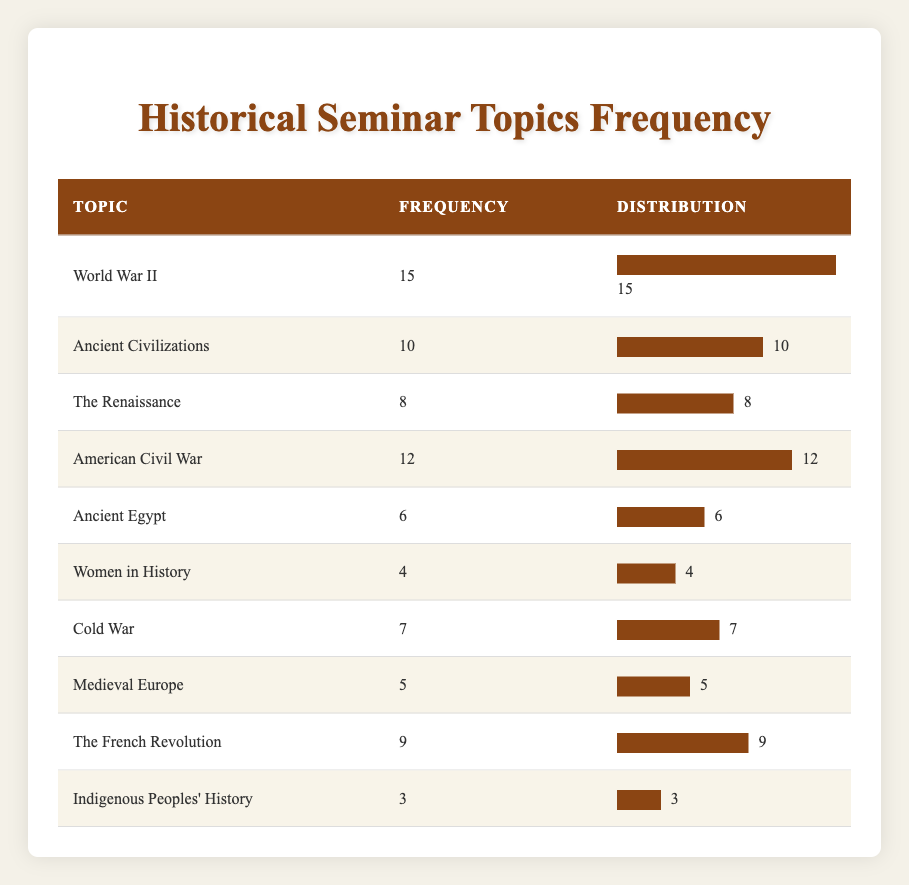What is the topic with the highest frequency? The topic with the highest frequency can be easily identified by looking for the maximum value in the Frequency column. Scanning through the data, World War II has the highest frequency of 15.
Answer: World War II How many times was Ancient Civilizations discussed? The Frequency column indicates that Ancient Civilizations was discussed 10 times.
Answer: 10 Which topic has the lowest frequency? To determine the topic with the lowest frequency, we look for the minimum value in the Frequency column. Indigenous Peoples' History, with a frequency of 3, is the lowest.
Answer: Indigenous Peoples' History What is the total frequency of all topics discussed? We need to sum all the frequencies listed in the Frequency column. Adding them (15 + 10 + 8 + 12 + 6 + 4 + 7 + 5 + 9 + 3) gives a total of 79 for all topics discussed.
Answer: 79 Is the frequency of Women in History greater than that of Medieval Europe? Comparing the frequencies, Women in History has a frequency of 4, while Medieval Europe has a frequency of 5. Since 4 is not greater than 5, the answer is no.
Answer: No How many topics have a frequency greater than 7? We count the topics in the table that have a frequency higher than 7. The topics are World War II (15), American Civil War (12), Ancient Civilizations (10), The Renaissance (8), and The French Revolution (9). This gives us a total of 5 topics.
Answer: 5 What is the average frequency of the topics discussed? To find the average frequency, we sum all frequencies (79) and divide by the number of topics (10). Thus, the average frequency is 79 divided by 10, which equals 7.9.
Answer: 7.9 Which topics have frequencies between 5 and 10 inclusive? We identify the topics whose frequencies fall within the specified range. The topics are Ancient Civilizations (10), The Renaissance (8), Cold War (7), and Medieval Europe (5). This results in a count of 4 topics within that range.
Answer: 4 If we combine the frequencies of World War II and American Civil War, what is the total? We add the frequencies of the two topics: World War II (15) and American Civil War (12). Adding them together gives us a combined total of 27.
Answer: 27 